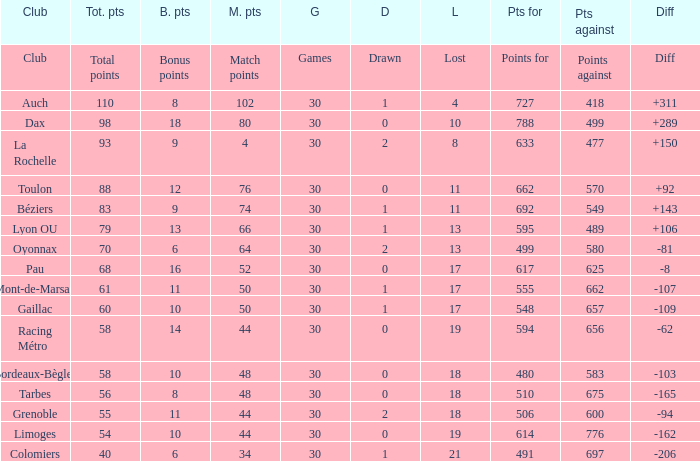What is the number of games for a club that has a value of 595 for points for? 30.0. 